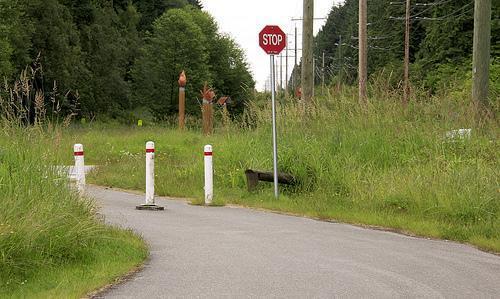How many white posts are there?
Give a very brief answer. 3. 